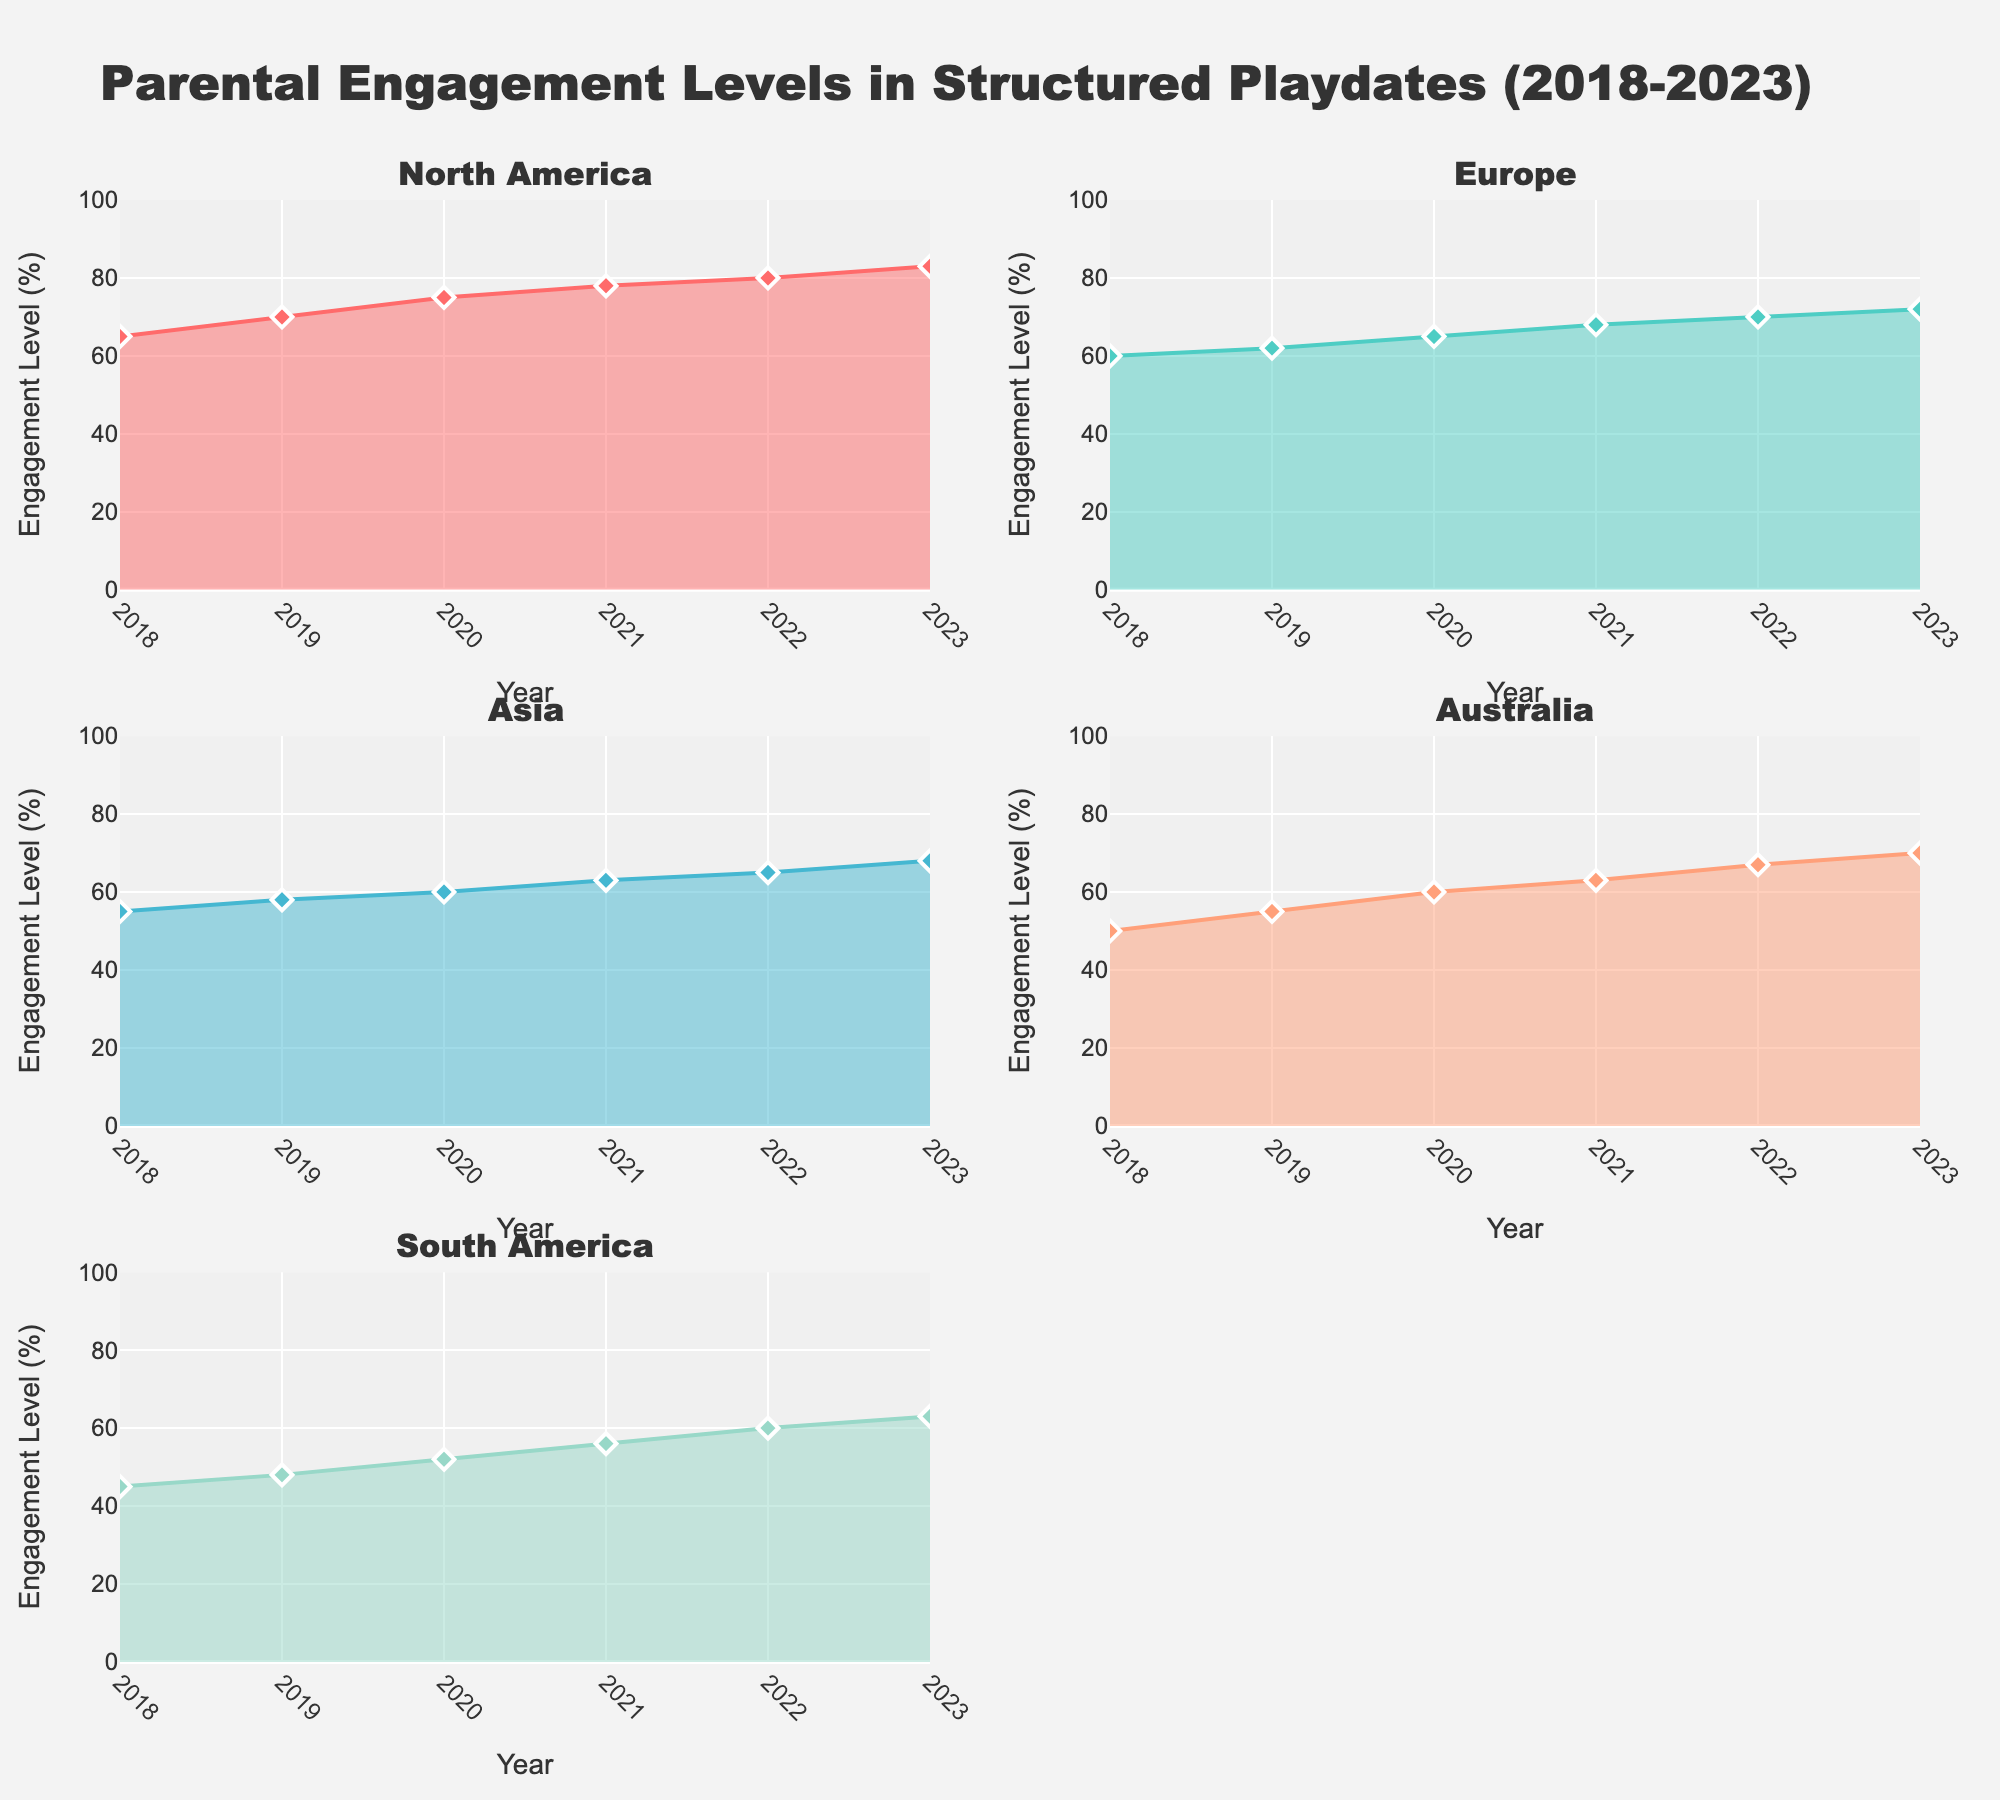Sum of engagement levels in North America from 2018 to 2023? Sum each engagement level (65 + 70 + 75 + 78 + 80 + 83) which equals 451
Answer: 451 Which region saw the largest increase in parental engagement from 2018 to 2023? Calculate the difference between 2023 and 2018 for each region. North America: 83-65=18, Europe: 72-60=12, Asia: 68-55=13, Australia: 70-50=20, South America: 63-45=18. Australia has the largest increase.
Answer: Australia What is the average engagement level across all regions in 2020? Average the engagement levels for 2020 by summing (75 + 65 + 60 + 60 + 52) and dividing by 5, which equals 62.4
Answer: 62.4 Which region consistently had the highest engagement levels over the years? Check the engagement level of each region across the years; North America consistently has the highest values.
Answer: North America How did parental engagement levels in South America change between 2018 and 2023? Calculate the change from 45 in 2018 to 63 in 2023. The difference is 18.
Answer: Increased by 18 Do all regions show an increasing trend in parental engagement from 2018 to 2023? Analyze each subplot to observe the trend line; all regions show a gradual increase over time.
Answer: Yes What was the engagement level in Asia in 2021? From the subplot for Asia, the engagement level in 2021 is 63.
Answer: 63 Which year had the highest increase in parental engagement in North America? Calculate year-over-year increases for North America: 5 (2018-2019), 5 (2019-2020), 3 (2020-2021), 2 (2021-2022), 3 (2022-2023); 2019 and 2020 both had the highest increase of 5.
Answer: 2019 and 2020 How much did the engagement level in Europe increase from 2018 to 2020? Subtract 2018 level from 2020 level in Europe. 65 - 60 = 5
Answer: 5 In which year did Australia's parental engagement level cross 60%? From the subplot for Australia, the engagement level crosses 60% in 2020
Answer: 2020 